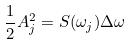Convert formula to latex. <formula><loc_0><loc_0><loc_500><loc_500>\frac { 1 } { 2 } A _ { j } ^ { 2 } = S ( \omega _ { j } ) \Delta \omega</formula> 